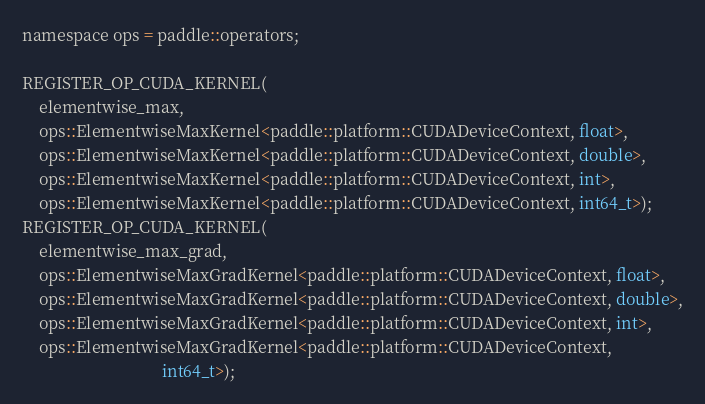<code> <loc_0><loc_0><loc_500><loc_500><_Cuda_>namespace ops = paddle::operators;

REGISTER_OP_CUDA_KERNEL(
    elementwise_max,
    ops::ElementwiseMaxKernel<paddle::platform::CUDADeviceContext, float>,
    ops::ElementwiseMaxKernel<paddle::platform::CUDADeviceContext, double>,
    ops::ElementwiseMaxKernel<paddle::platform::CUDADeviceContext, int>,
    ops::ElementwiseMaxKernel<paddle::platform::CUDADeviceContext, int64_t>);
REGISTER_OP_CUDA_KERNEL(
    elementwise_max_grad,
    ops::ElementwiseMaxGradKernel<paddle::platform::CUDADeviceContext, float>,
    ops::ElementwiseMaxGradKernel<paddle::platform::CUDADeviceContext, double>,
    ops::ElementwiseMaxGradKernel<paddle::platform::CUDADeviceContext, int>,
    ops::ElementwiseMaxGradKernel<paddle::platform::CUDADeviceContext,
                                  int64_t>);
</code> 